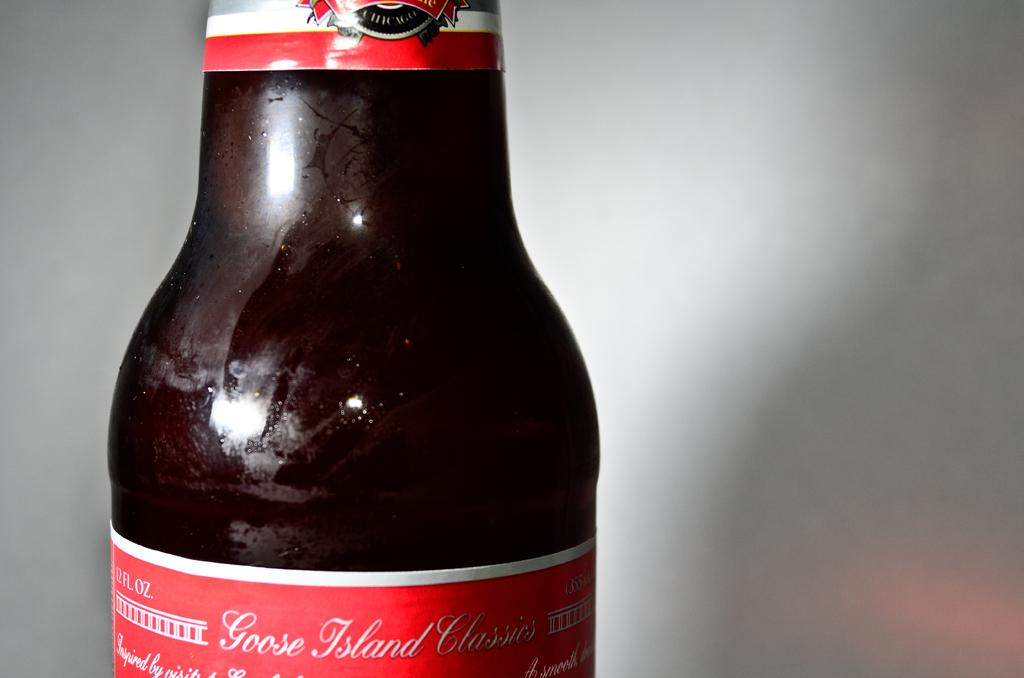Provide a one-sentence caption for the provided image. A close up is shown of a bottle of Goose Island Classics. 